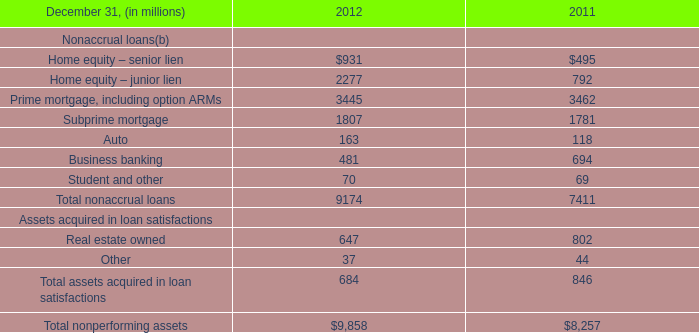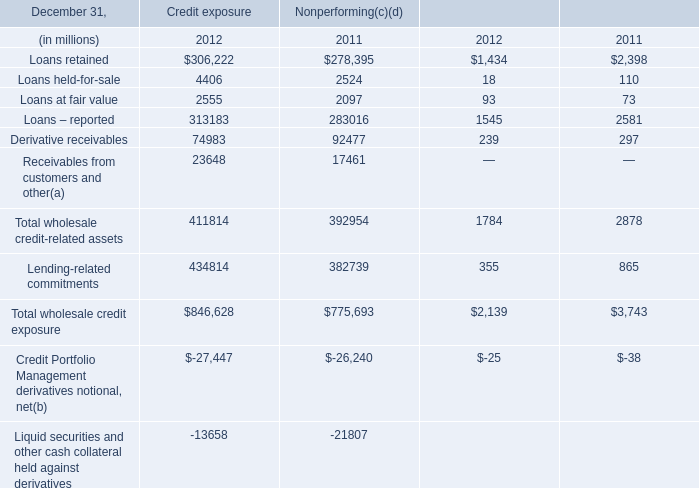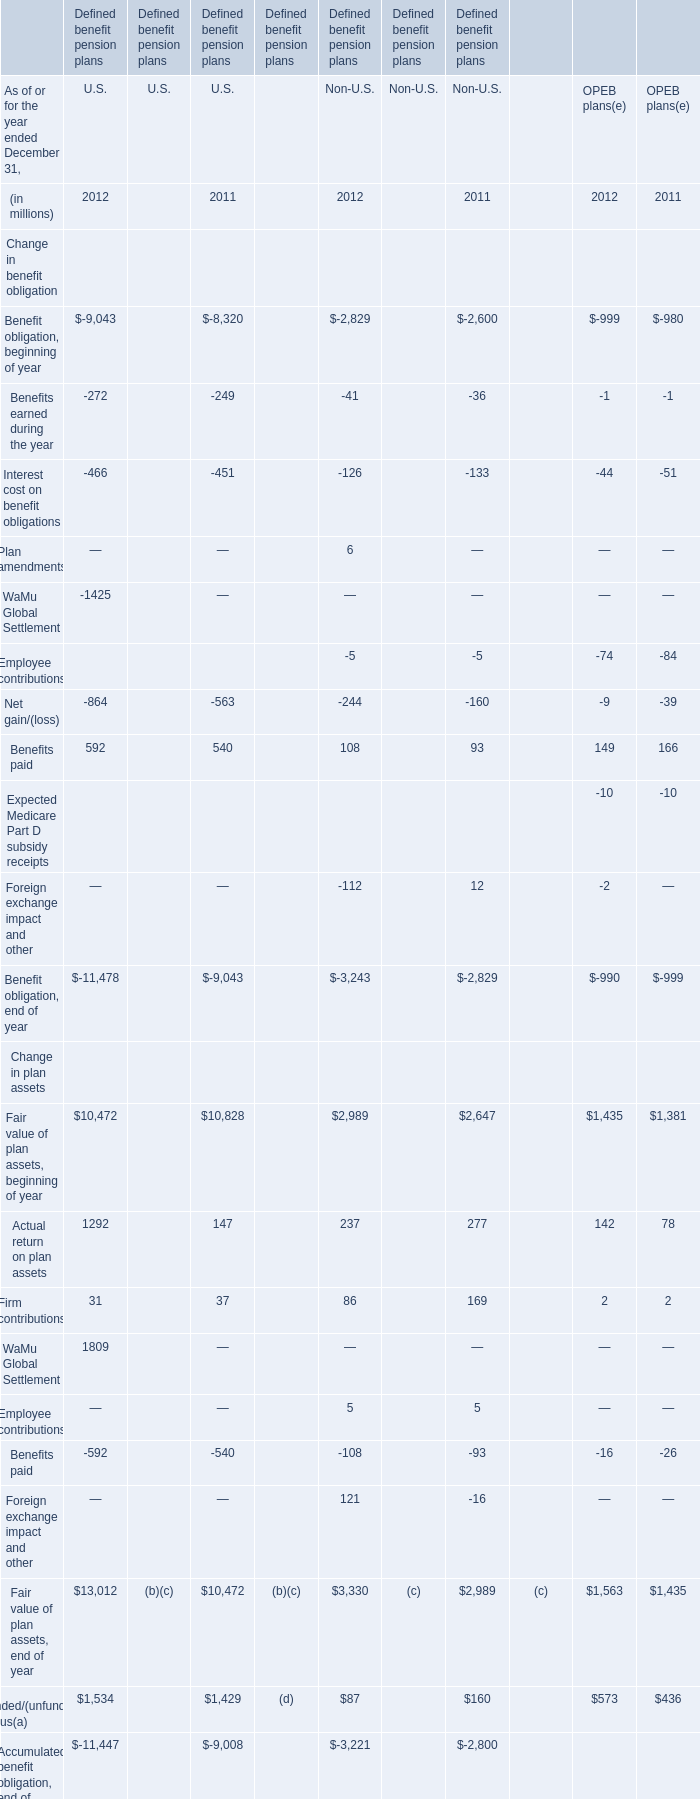What's the sum of Prime mortgage, including option ARMs of 2011, and Loans retained of Nonperforming 2011 ? 
Computations: (3462.0 + 278395.0)
Answer: 281857.0. 